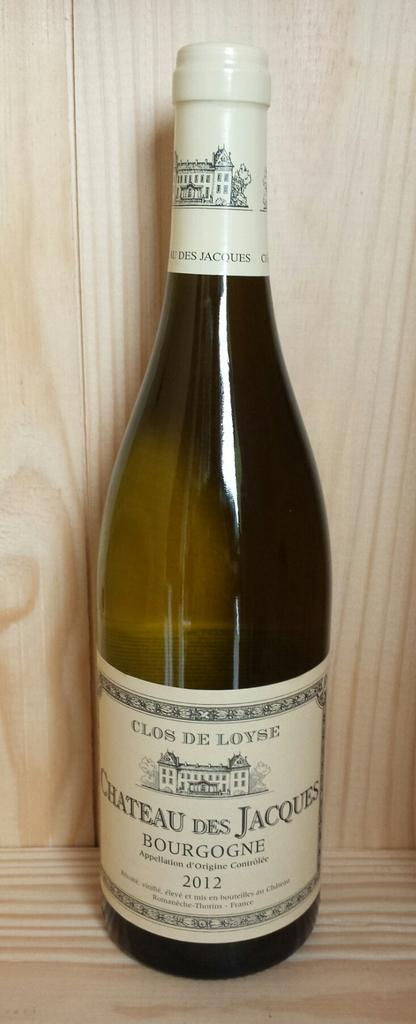<image>
Offer a succinct explanation of the picture presented. a new unopened bottle of chateau des jaques in a cupboard. 